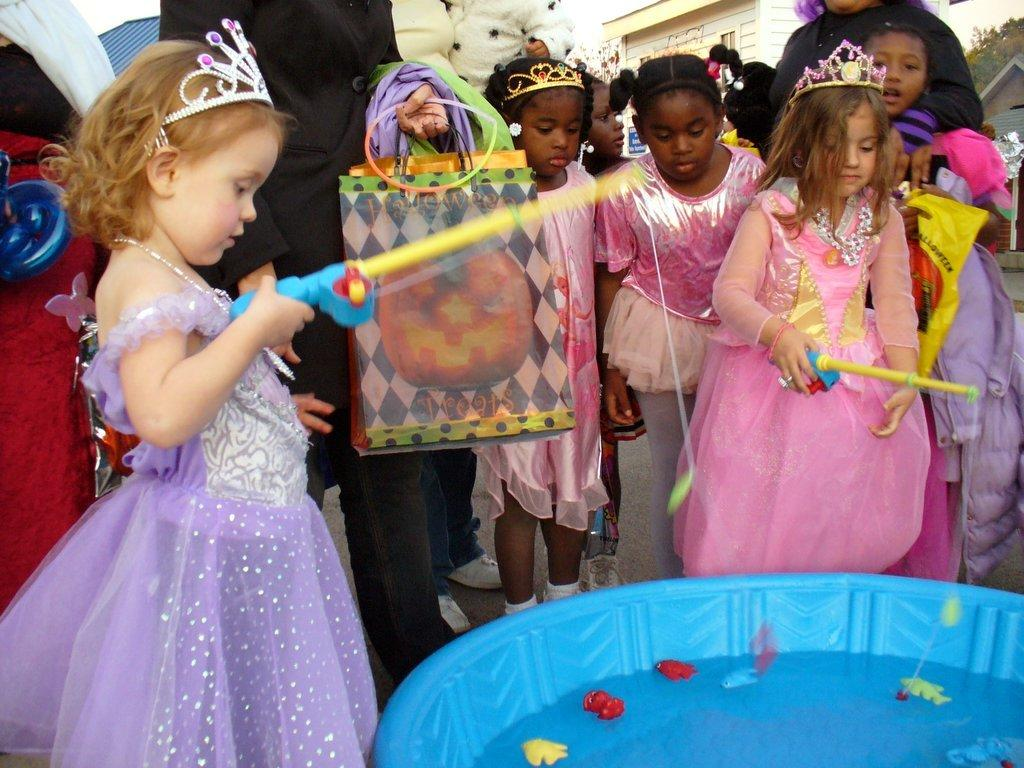Who is present in the image? There are children in the image. Can you describe the gender of the majority of the children? Most of the children are girls. What can be seen at the bottom of the picture? There is a blue color water tub in the bottom of the picture. What is the purpose of the kitten in the image? There is no kitten present in the image, so it cannot serve any purpose within the context of the image. 